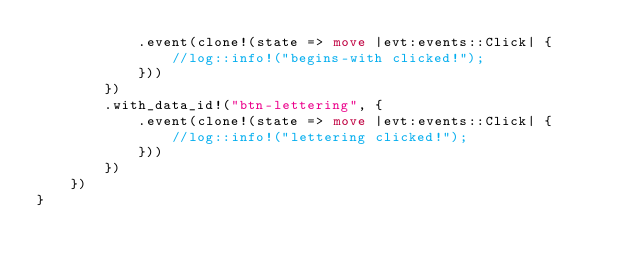Convert code to text. <code><loc_0><loc_0><loc_500><loc_500><_Rust_>            .event(clone!(state => move |evt:events::Click| {
                //log::info!("begins-with clicked!");
            }))
        })
        .with_data_id!("btn-lettering", {
            .event(clone!(state => move |evt:events::Click| {
                //log::info!("lettering clicked!");
            }))
        })
    })
}
</code> 